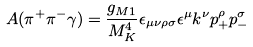<formula> <loc_0><loc_0><loc_500><loc_500>A ( \pi ^ { + } \pi ^ { - } \gamma ) = \frac { g _ { M 1 } } { M ^ { 4 } _ { K } } \epsilon _ { \mu \nu \rho \sigma } \epsilon ^ { \mu } k ^ { \nu } p ^ { \rho } _ { + } p ^ { \sigma } _ { - }</formula> 